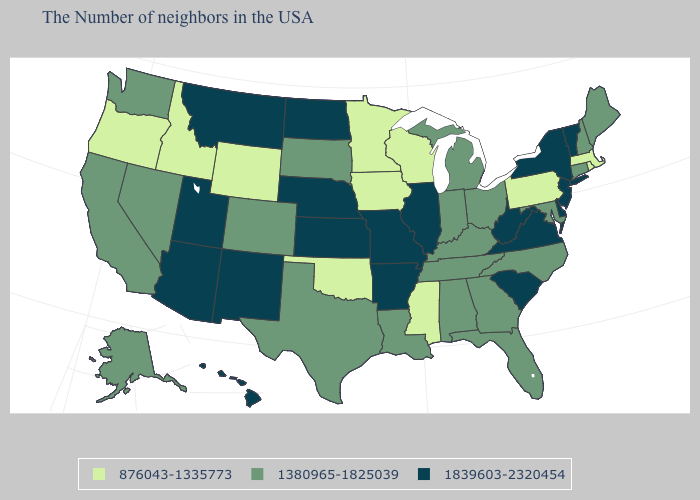Does West Virginia have the highest value in the South?
Give a very brief answer. Yes. Does the first symbol in the legend represent the smallest category?
Answer briefly. Yes. How many symbols are there in the legend?
Quick response, please. 3. Among the states that border Minnesota , which have the lowest value?
Quick response, please. Wisconsin, Iowa. What is the value of Vermont?
Give a very brief answer. 1839603-2320454. Name the states that have a value in the range 1380965-1825039?
Answer briefly. Maine, New Hampshire, Connecticut, Maryland, North Carolina, Ohio, Florida, Georgia, Michigan, Kentucky, Indiana, Alabama, Tennessee, Louisiana, Texas, South Dakota, Colorado, Nevada, California, Washington, Alaska. Name the states that have a value in the range 876043-1335773?
Give a very brief answer. Massachusetts, Rhode Island, Pennsylvania, Wisconsin, Mississippi, Minnesota, Iowa, Oklahoma, Wyoming, Idaho, Oregon. What is the value of Georgia?
Short answer required. 1380965-1825039. Does Wyoming have the lowest value in the USA?
Short answer required. Yes. Among the states that border Minnesota , which have the highest value?
Concise answer only. North Dakota. Which states have the lowest value in the MidWest?
Short answer required. Wisconsin, Minnesota, Iowa. Name the states that have a value in the range 1839603-2320454?
Write a very short answer. Vermont, New York, New Jersey, Delaware, Virginia, South Carolina, West Virginia, Illinois, Missouri, Arkansas, Kansas, Nebraska, North Dakota, New Mexico, Utah, Montana, Arizona, Hawaii. What is the lowest value in the USA?
Keep it brief. 876043-1335773. Name the states that have a value in the range 876043-1335773?
Concise answer only. Massachusetts, Rhode Island, Pennsylvania, Wisconsin, Mississippi, Minnesota, Iowa, Oklahoma, Wyoming, Idaho, Oregon. 